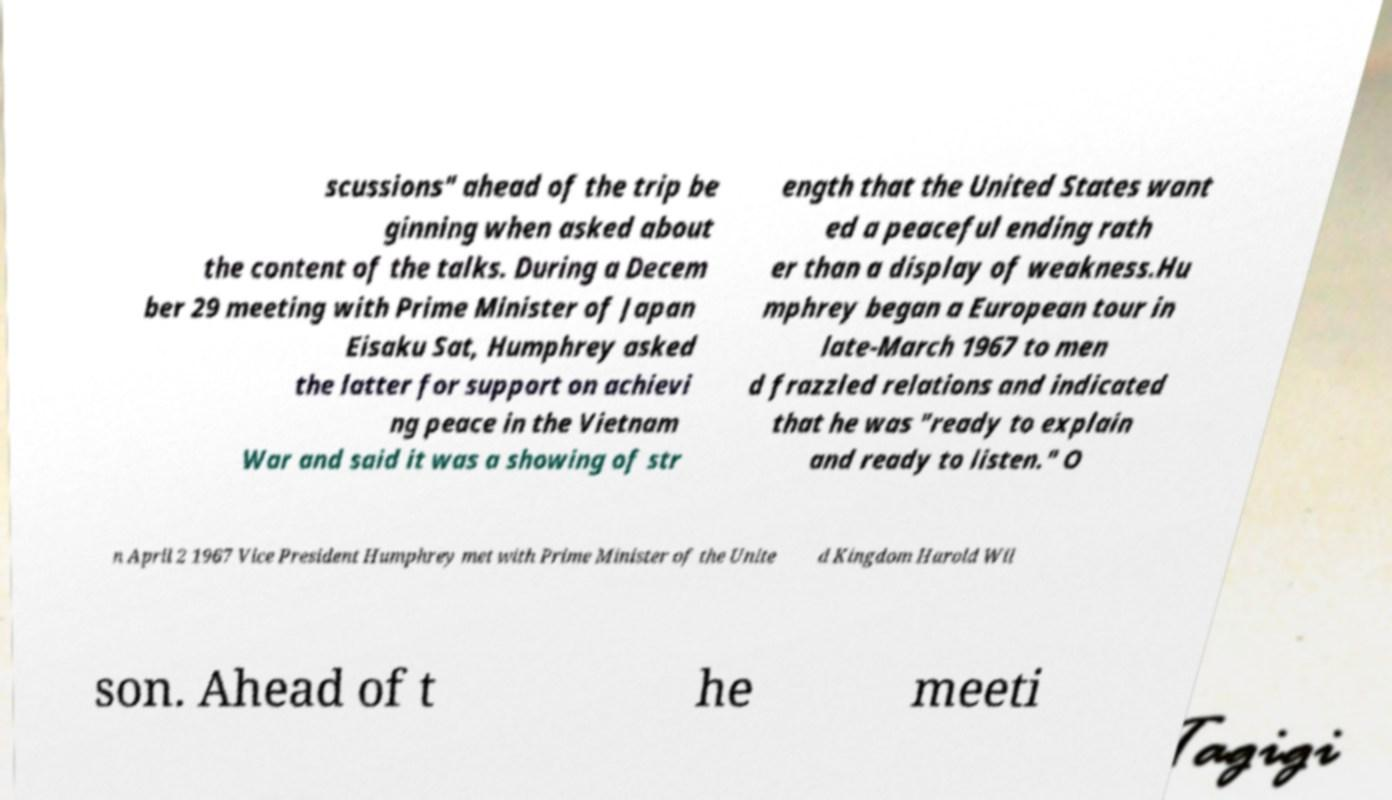What messages or text are displayed in this image? I need them in a readable, typed format. scussions" ahead of the trip be ginning when asked about the content of the talks. During a Decem ber 29 meeting with Prime Minister of Japan Eisaku Sat, Humphrey asked the latter for support on achievi ng peace in the Vietnam War and said it was a showing of str ength that the United States want ed a peaceful ending rath er than a display of weakness.Hu mphrey began a European tour in late-March 1967 to men d frazzled relations and indicated that he was "ready to explain and ready to listen." O n April 2 1967 Vice President Humphrey met with Prime Minister of the Unite d Kingdom Harold Wil son. Ahead of t he meeti 